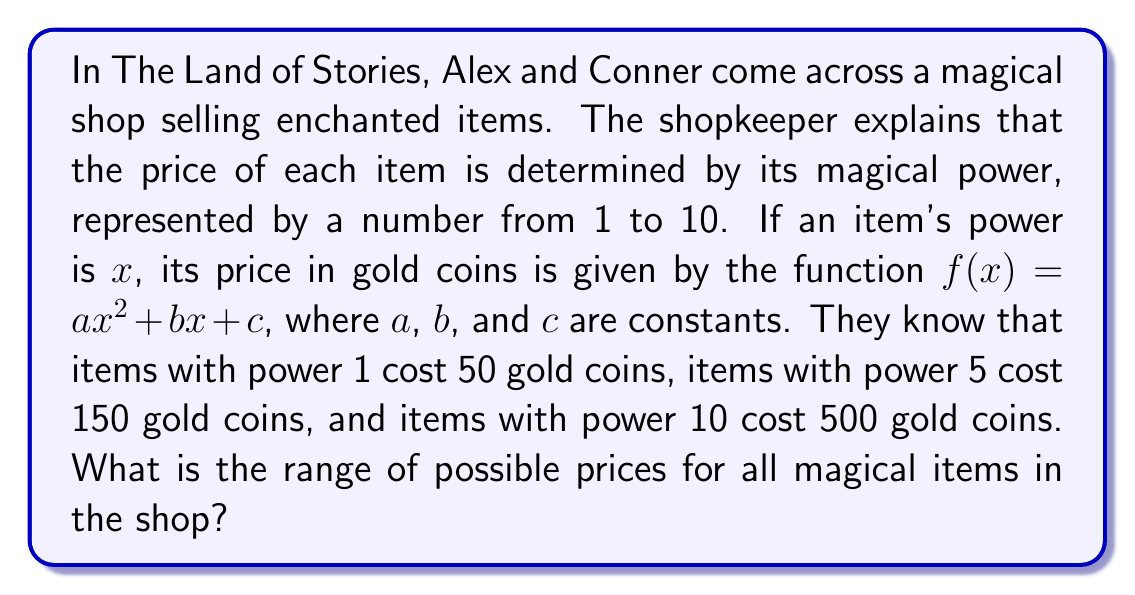Help me with this question. Let's solve this step-by-step:

1) We have three equations based on the given information:
   $$f(1) = a(1)^2 + b(1) + c = 50$$
   $$f(5) = a(5)^2 + b(5) + c = 150$$
   $$f(10) = a(10)^2 + b(10) + c = 500$$

2) Simplify:
   $$a + b + c = 50$$ (Equation 1)
   $$25a + 5b + c = 150$$ (Equation 2)
   $$100a + 10b + c = 500$$ (Equation 3)

3) Subtract Equation 1 from Equation 2:
   $$24a + 4b = 100$$
   $$6a + b = 25$$ (Equation 4)

4) Subtract Equation 1 from Equation 3:
   $$99a + 9b = 450$$
   $$11a + b = 50$$ (Equation 5)

5) Subtract Equation 4 from Equation 5:
   $$5a = 25$$
   $$a = 5$$

6) Substitute $a = 5$ into Equation 4:
   $$30 + b = 25$$
   $$b = -5$$

7) Substitute $a = 5$ and $b = -5$ into Equation 1:
   $$5 + (-5) + c = 50$$
   $$c = 50$$

8) Therefore, the function is $f(x) = 5x^2 - 5x + 50$

9) To find the range, we need to find the minimum value of this quadratic function:
   The axis of symmetry is at $x = \frac{-b}{2a} = \frac{5}{10} = 0.5$

10) Since $x$ is restricted to integers from 1 to 10, the minimum value will occur at either $x = 1$ or $x = 2$

11) $f(1) = 5(1)^2 - 5(1) + 50 = 50$
    $f(2) = 5(2)^2 - 5(2) + 50 = 70$

12) The maximum value occurs at $x = 10$:
    $f(10) = 5(10)^2 - 5(10) + 50 = 500$

Therefore, the range of possible prices is from 50 to 500 gold coins.
Answer: $[50, 500]$ 